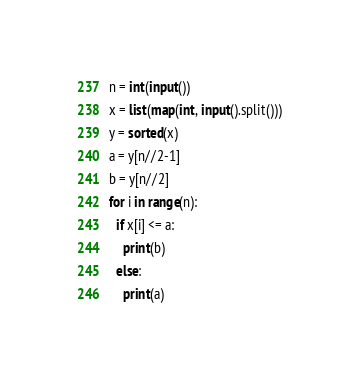<code> <loc_0><loc_0><loc_500><loc_500><_Python_>n = int(input())
x = list(map(int, input().split()))
y = sorted(x)
a = y[n//2-1]
b = y[n//2]
for i in range(n):
  if x[i] <= a:
    print(b)
  else:
    print(a)</code> 